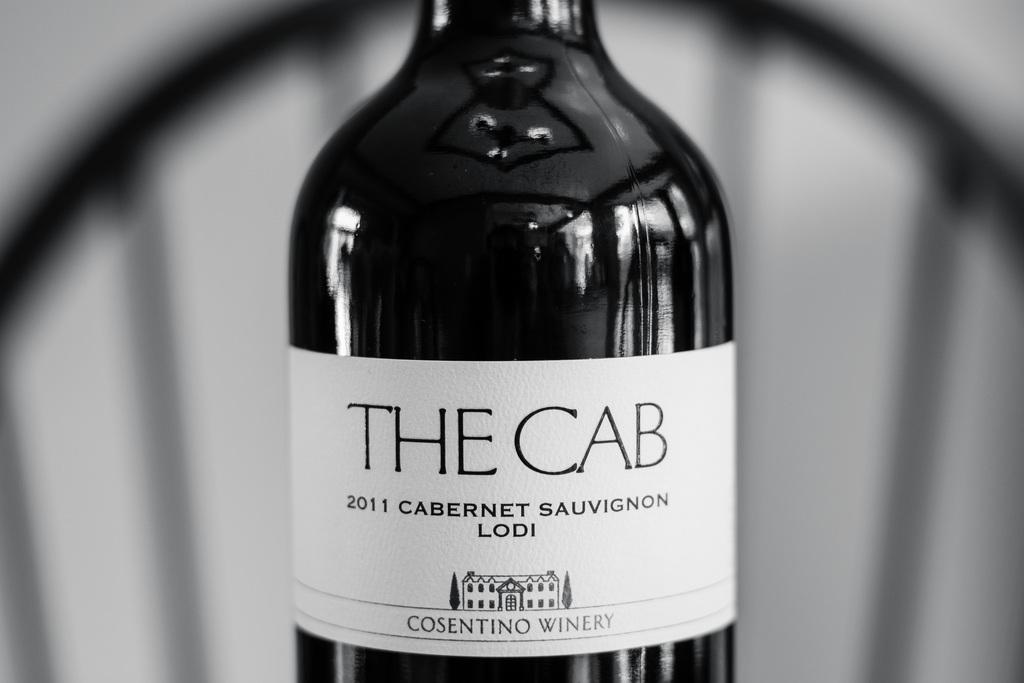What year is this wine?
Make the answer very short. 2011. What is the name of the wine?
Give a very brief answer. The cab. 